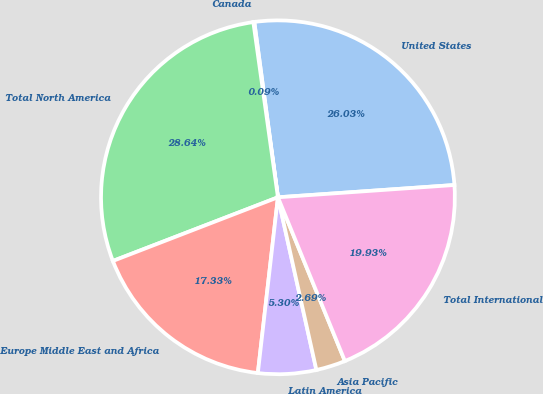<chart> <loc_0><loc_0><loc_500><loc_500><pie_chart><fcel>United States<fcel>Canada<fcel>Total North America<fcel>Europe Middle East and Africa<fcel>Latin America<fcel>Asia Pacific<fcel>Total International<nl><fcel>26.03%<fcel>0.09%<fcel>28.64%<fcel>17.33%<fcel>5.3%<fcel>2.69%<fcel>19.93%<nl></chart> 